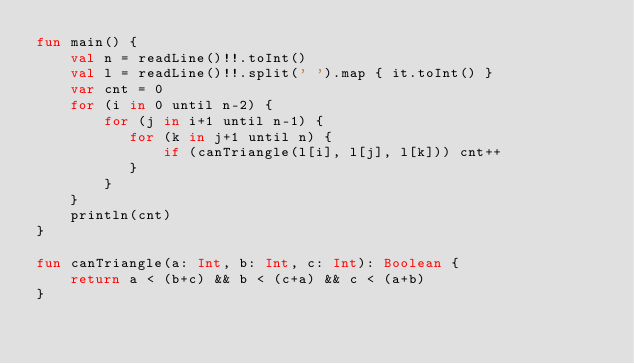Convert code to text. <code><loc_0><loc_0><loc_500><loc_500><_Kotlin_>fun main() {
    val n = readLine()!!.toInt()
    val l = readLine()!!.split(' ').map { it.toInt() }
    var cnt = 0
    for (i in 0 until n-2) {
        for (j in i+1 until n-1) {
           for (k in j+1 until n) {
               if (canTriangle(l[i], l[j], l[k])) cnt++
           }
        }
    }
    println(cnt)
}

fun canTriangle(a: Int, b: Int, c: Int): Boolean {
    return a < (b+c) && b < (c+a) && c < (a+b)
}
</code> 